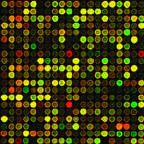re the necrotic cells being utilized to identify mutations that can be targeted by drugs?
Answer the question using a single word or phrase. No 